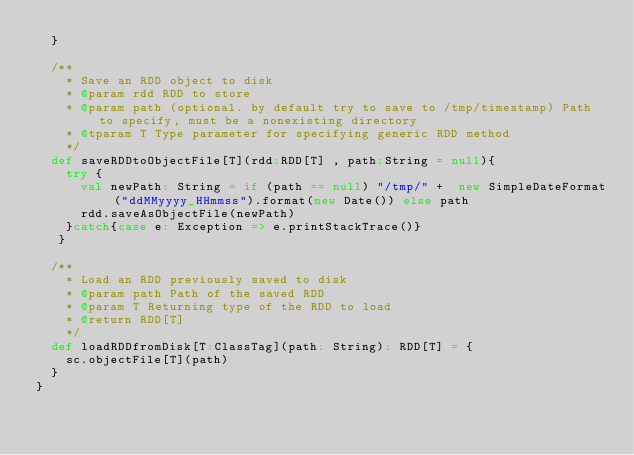<code> <loc_0><loc_0><loc_500><loc_500><_Scala_>  }

  /**
    * Save an RDD object to disk
    * @param rdd RDD to store
    * @param path (optional. by default try to save to /tmp/timestamp) Path to specify, must be a nonexisting directory
    * @tparam T Type parameter for specifying generic RDD method
    */
  def saveRDDtoObjectFile[T](rdd:RDD[T] , path:String = null){
    try {
      val newPath: String = if (path == null) "/tmp/" +  new SimpleDateFormat("ddMMyyyy_HHmmss").format(new Date()) else path
      rdd.saveAsObjectFile(newPath)
    }catch{case e: Exception => e.printStackTrace()}
   }

  /**
    * Load an RDD previously saved to disk
    * @param path Path of the saved RDD
    * @param T Returning type of the RDD to load
    * @return RDD[T]
    */
  def loadRDDfromDisk[T:ClassTag](path: String): RDD[T] = {
    sc.objectFile[T](path)
  }
}
</code> 